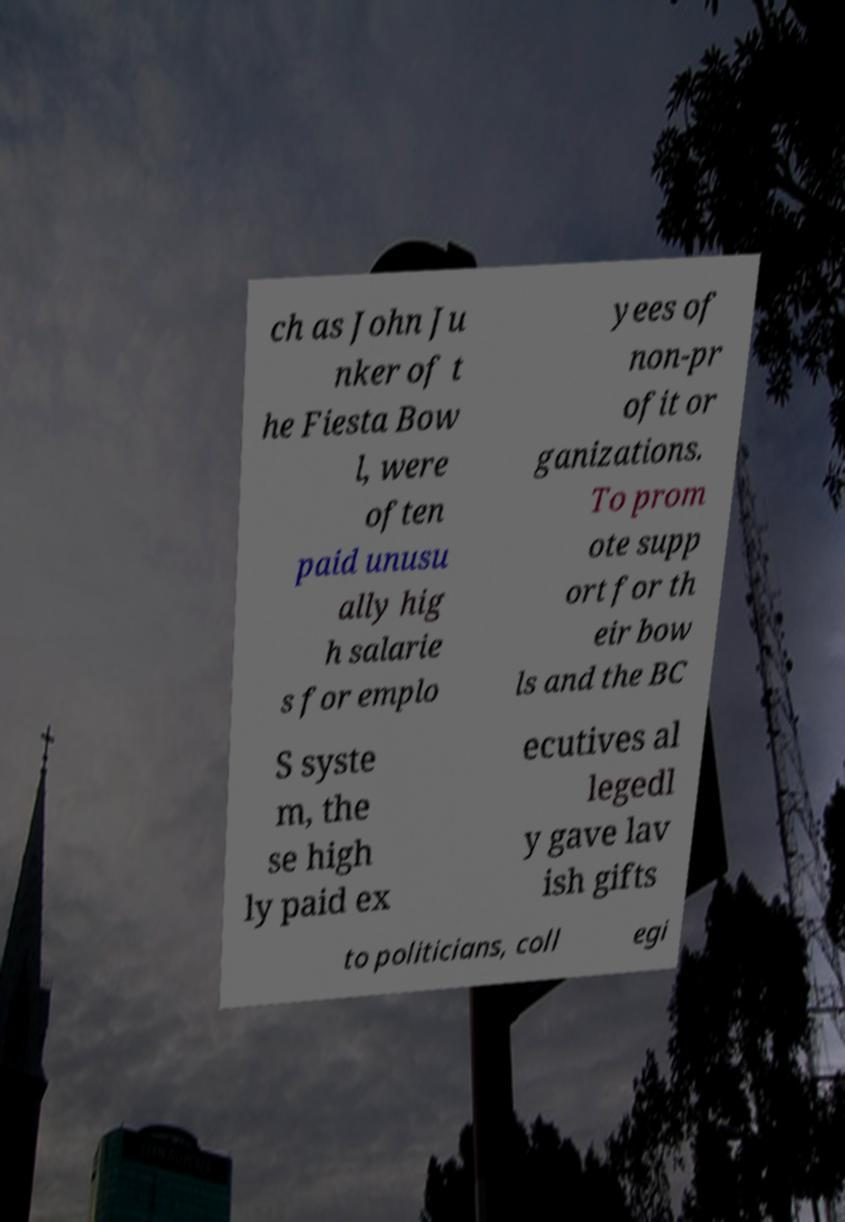What messages or text are displayed in this image? I need them in a readable, typed format. ch as John Ju nker of t he Fiesta Bow l, were often paid unusu ally hig h salarie s for emplo yees of non-pr ofit or ganizations. To prom ote supp ort for th eir bow ls and the BC S syste m, the se high ly paid ex ecutives al legedl y gave lav ish gifts to politicians, coll egi 